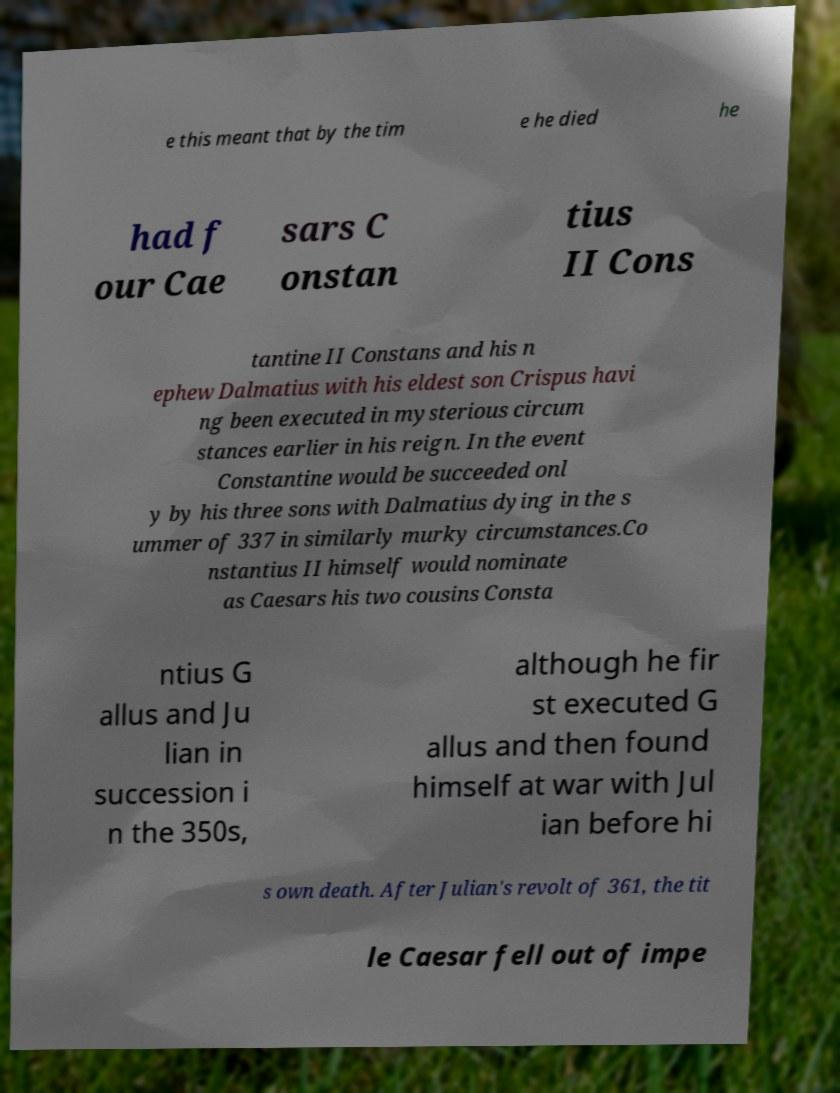There's text embedded in this image that I need extracted. Can you transcribe it verbatim? e this meant that by the tim e he died he had f our Cae sars C onstan tius II Cons tantine II Constans and his n ephew Dalmatius with his eldest son Crispus havi ng been executed in mysterious circum stances earlier in his reign. In the event Constantine would be succeeded onl y by his three sons with Dalmatius dying in the s ummer of 337 in similarly murky circumstances.Co nstantius II himself would nominate as Caesars his two cousins Consta ntius G allus and Ju lian in succession i n the 350s, although he fir st executed G allus and then found himself at war with Jul ian before hi s own death. After Julian's revolt of 361, the tit le Caesar fell out of impe 